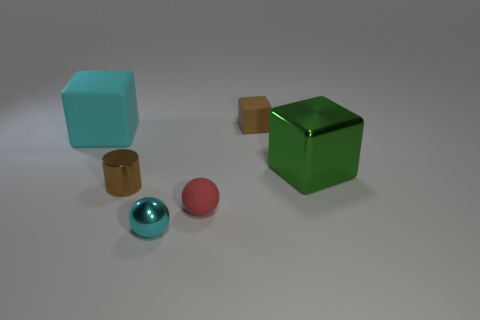What number of purple rubber objects are the same shape as the tiny cyan shiny object?
Your answer should be very brief. 0. How many large green metal blocks are behind the small object that is behind the cyan cube?
Offer a terse response. 0. What number of shiny things are either small cyan balls or green things?
Your response must be concise. 2. Is there a brown cube made of the same material as the green object?
Provide a short and direct response. No. How many things are either small brown objects in front of the cyan rubber object or brown things that are in front of the brown matte cube?
Your answer should be very brief. 1. There is a object that is in front of the rubber sphere; does it have the same color as the big metallic cube?
Your response must be concise. No. How many other things are the same color as the metallic block?
Your answer should be compact. 0. What is the tiny cube made of?
Provide a short and direct response. Rubber. Is the size of the brown thing that is behind the green metallic object the same as the big matte thing?
Provide a succinct answer. No. What size is the cyan metallic object that is the same shape as the red rubber object?
Provide a succinct answer. Small. 